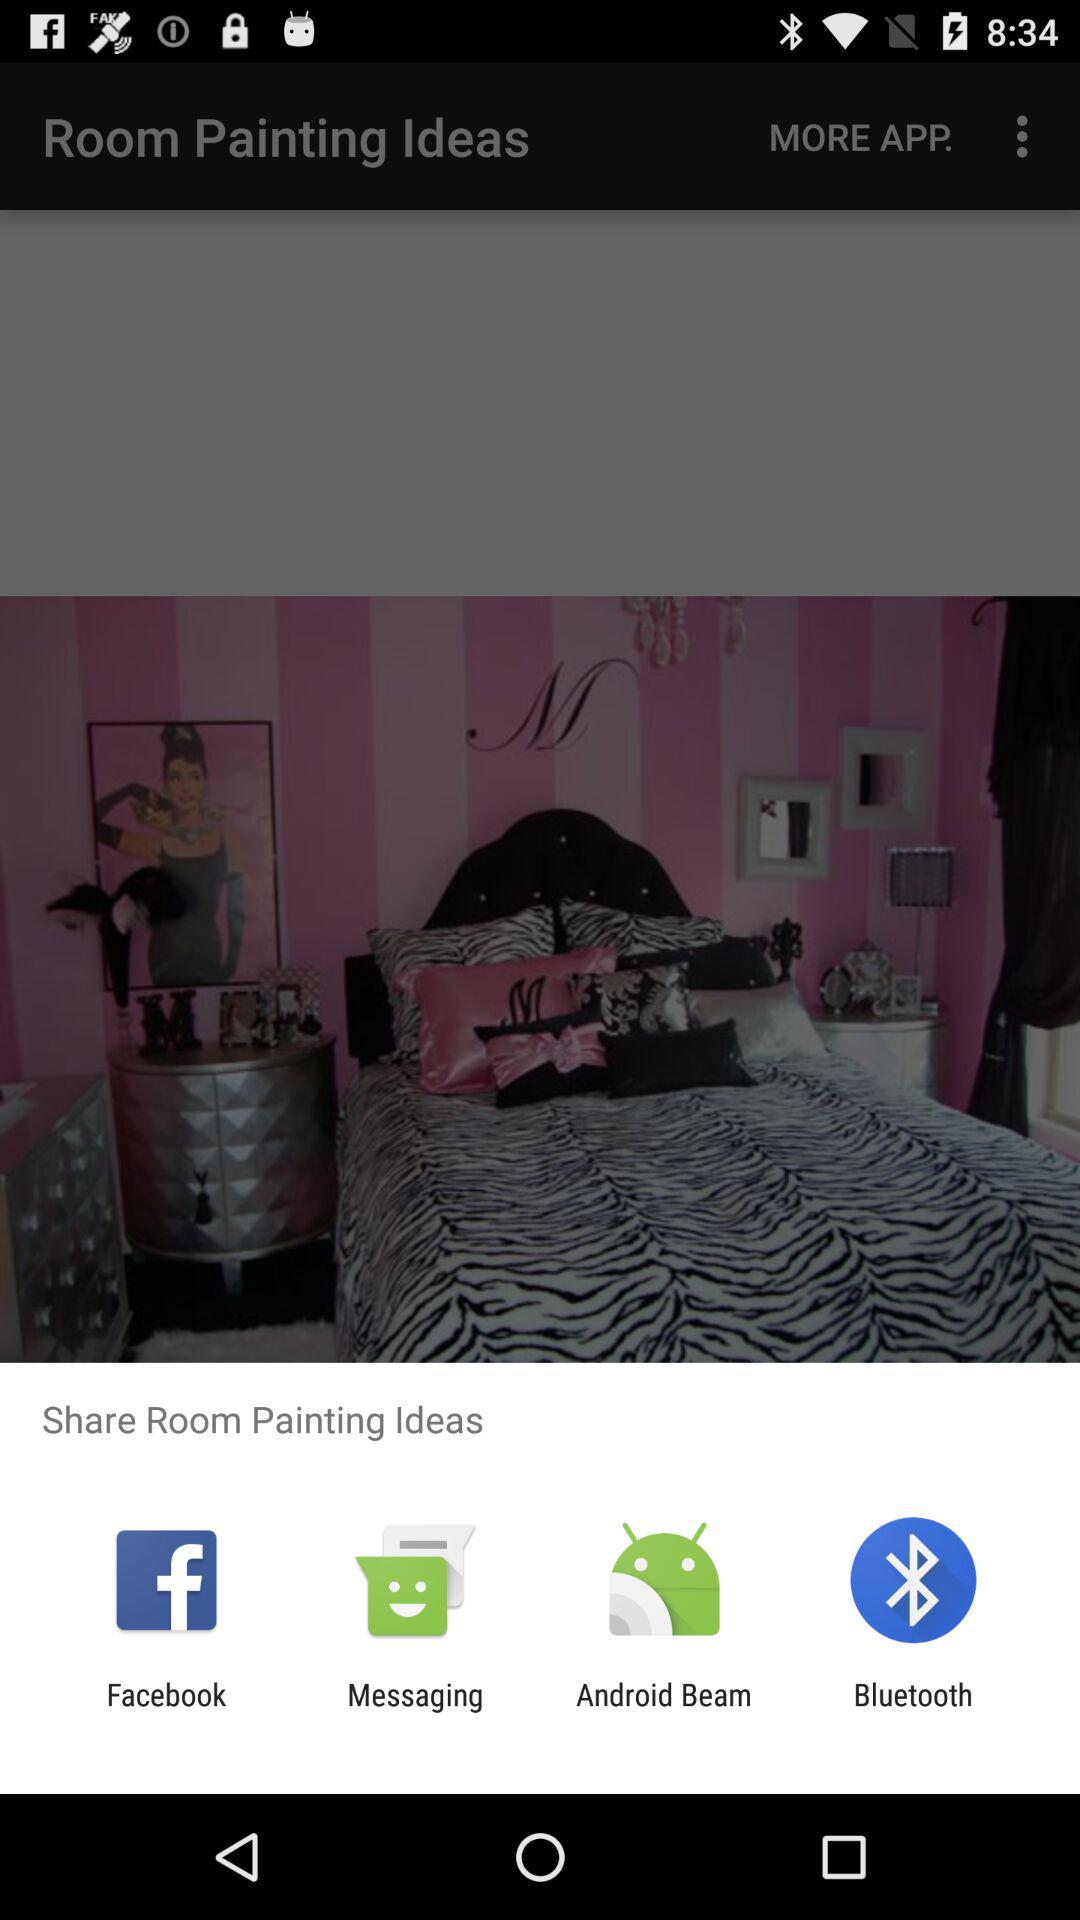What are the available options through which we can share "Room Painting Ideas"? The available options are "Facebook", "Messaging", "Android Beam" and "Bluetooth". 